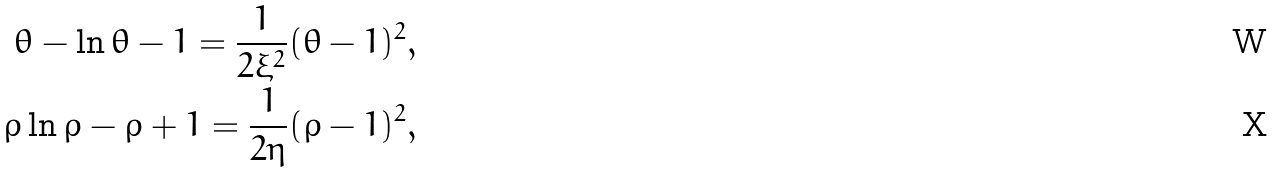Convert formula to latex. <formula><loc_0><loc_0><loc_500><loc_500>\theta - \ln \theta - 1 = \frac { 1 } { 2 \xi ^ { 2 } } ( \theta - 1 ) ^ { 2 } , \\ \rho \ln \rho - \rho + 1 = \frac { 1 } { 2 \eta } ( \rho - 1 ) ^ { 2 } ,</formula> 